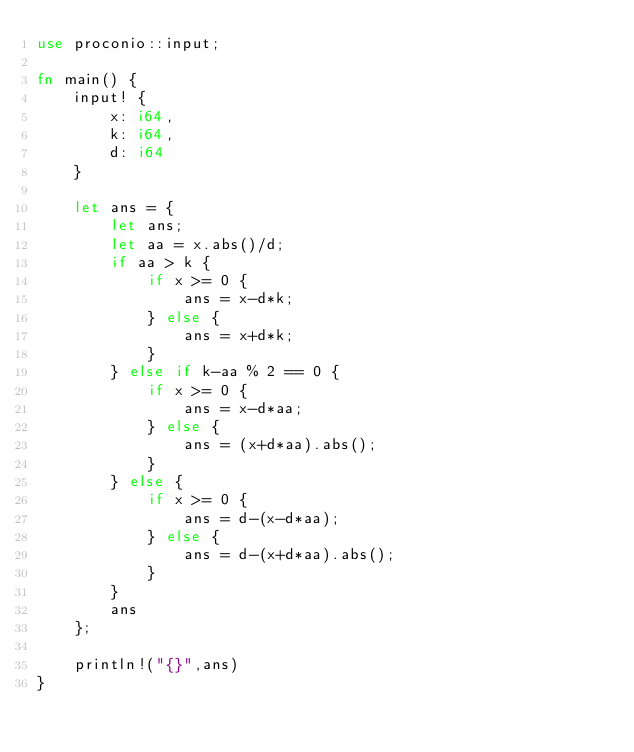<code> <loc_0><loc_0><loc_500><loc_500><_Rust_>use proconio::input;

fn main() {
    input! {
        x: i64,
        k: i64,
        d: i64
    }

    let ans = {
        let ans;
        let aa = x.abs()/d;
        if aa > k {
            if x >= 0 {
                ans = x-d*k;
            } else {
                ans = x+d*k;
            }
        } else if k-aa % 2 == 0 {
            if x >= 0 {
                ans = x-d*aa;
            } else {
                ans = (x+d*aa).abs();
            }
        } else {
            if x >= 0 {
                ans = d-(x-d*aa);
            } else {
                ans = d-(x+d*aa).abs();
            }
        }
        ans
    };

    println!("{}",ans)
}</code> 